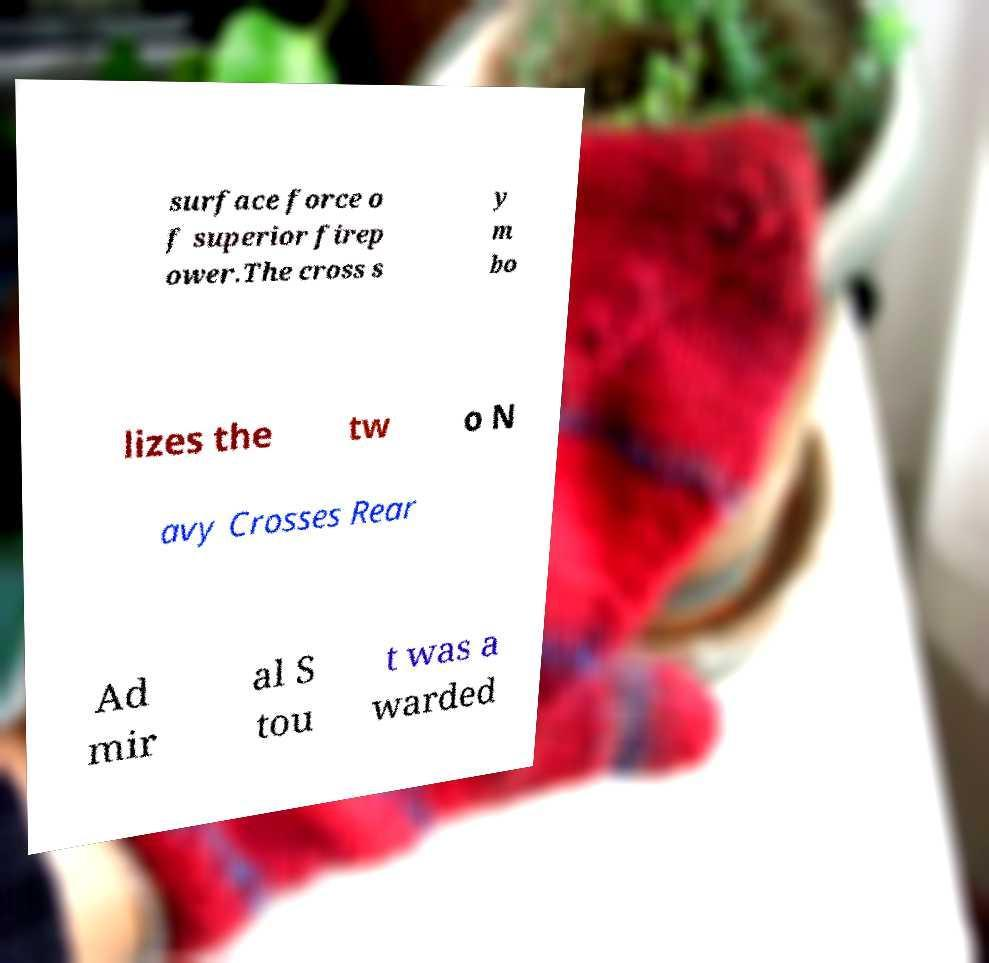Can you read and provide the text displayed in the image?This photo seems to have some interesting text. Can you extract and type it out for me? surface force o f superior firep ower.The cross s y m bo lizes the tw o N avy Crosses Rear Ad mir al S tou t was a warded 